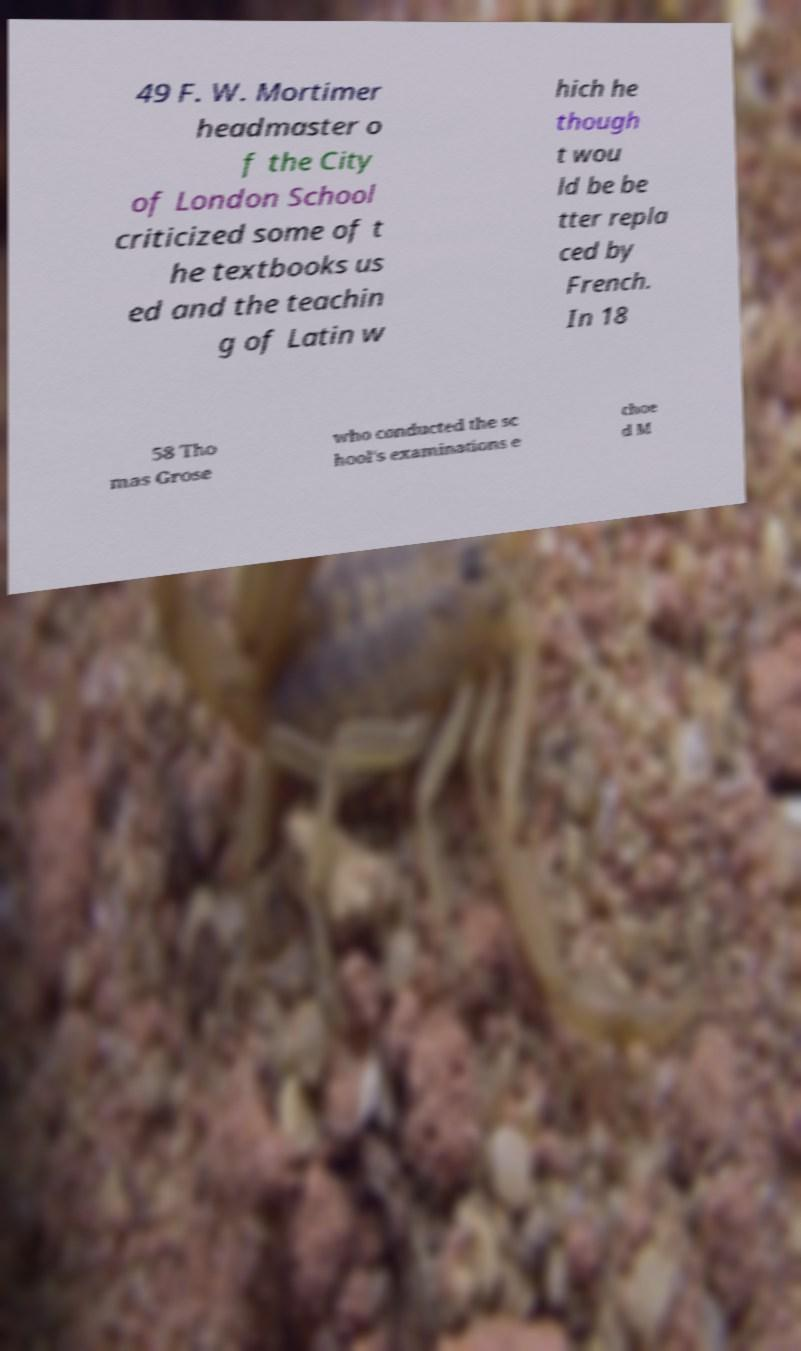Can you read and provide the text displayed in the image?This photo seems to have some interesting text. Can you extract and type it out for me? 49 F. W. Mortimer headmaster o f the City of London School criticized some of t he textbooks us ed and the teachin g of Latin w hich he though t wou ld be be tter repla ced by French. In 18 58 Tho mas Grose who conducted the sc hool's examinations e choe d M 